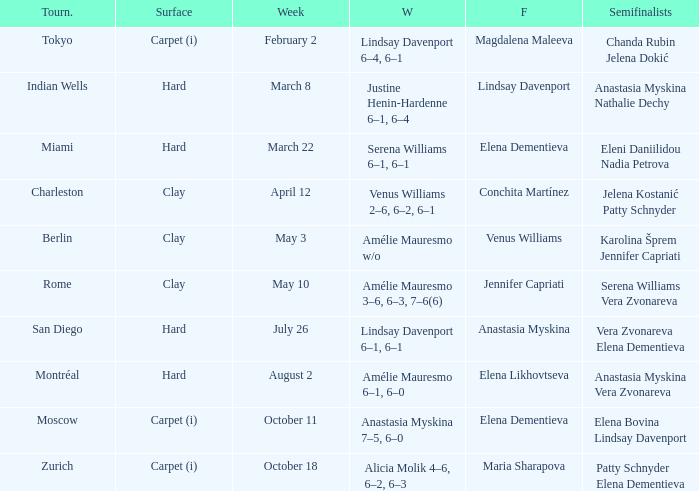Who were the semifinalists in the Rome tournament? Serena Williams Vera Zvonareva. 